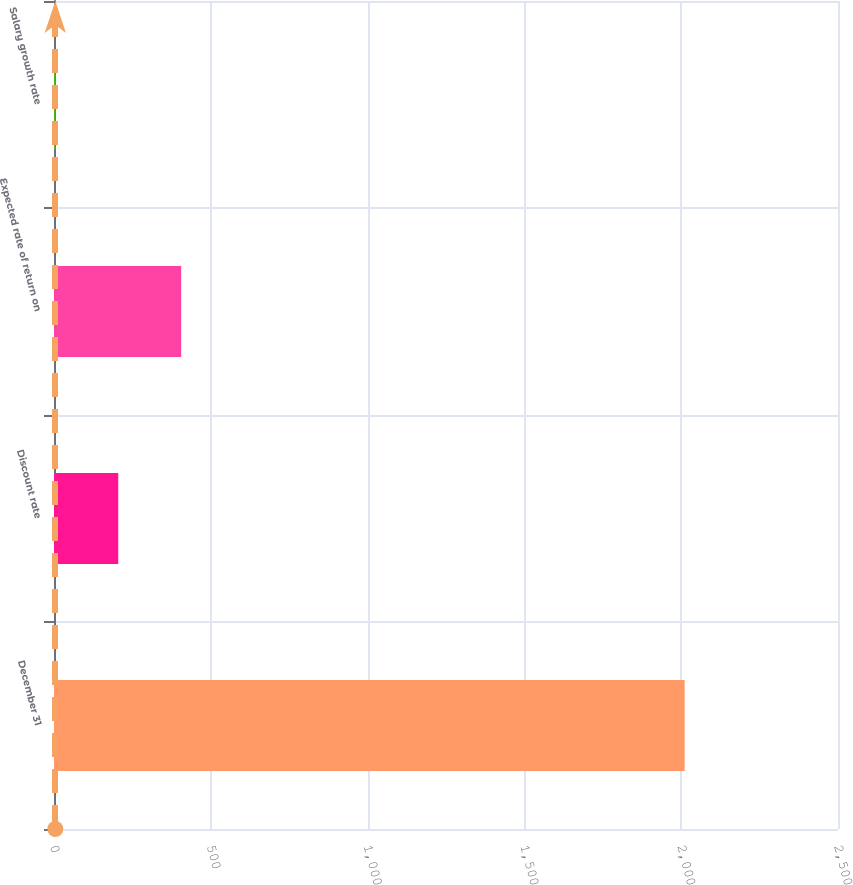Convert chart to OTSL. <chart><loc_0><loc_0><loc_500><loc_500><bar_chart><fcel>December 31<fcel>Discount rate<fcel>Expected rate of return on<fcel>Salary growth rate<nl><fcel>2011<fcel>204.88<fcel>405.56<fcel>4.2<nl></chart> 